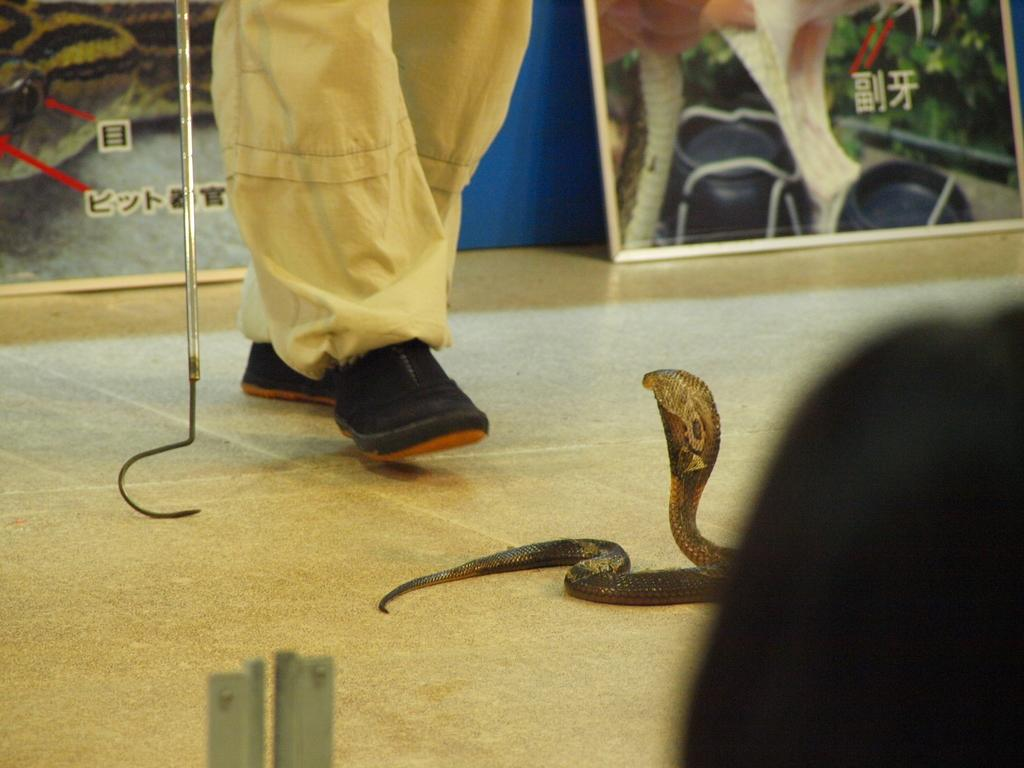What type of animal is in the image? There is a snake in the image. What else can be seen in the image besides the snake? There are person's legs holding a metal rod in the image. What is attached to the board in the image? There are posters of snakes attached to a board in the image. Where is the hydrant located in the image? There is no hydrant present in the image. What type of goat can be seen interacting with the snake in the image? There is no goat present in the image; it only features a snake and a person's legs holding a metal rod. 